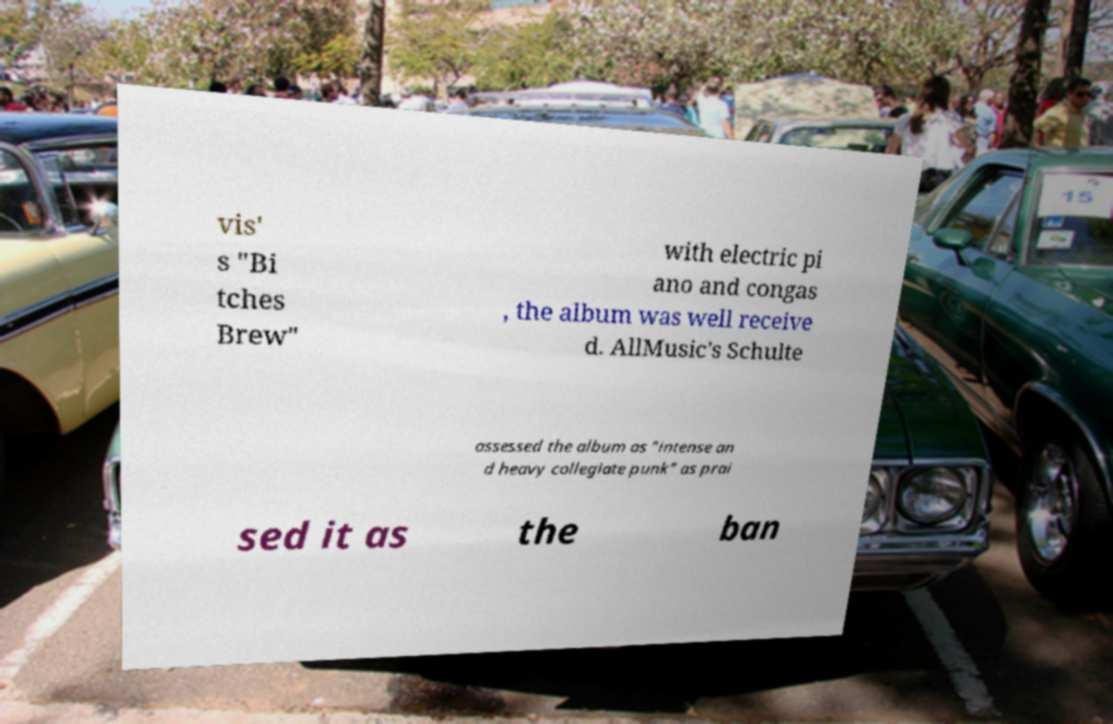Could you extract and type out the text from this image? vis' s "Bi tches Brew" with electric pi ano and congas , the album was well receive d. AllMusic's Schulte assessed the album as "intense an d heavy collegiate punk" as prai sed it as the ban 